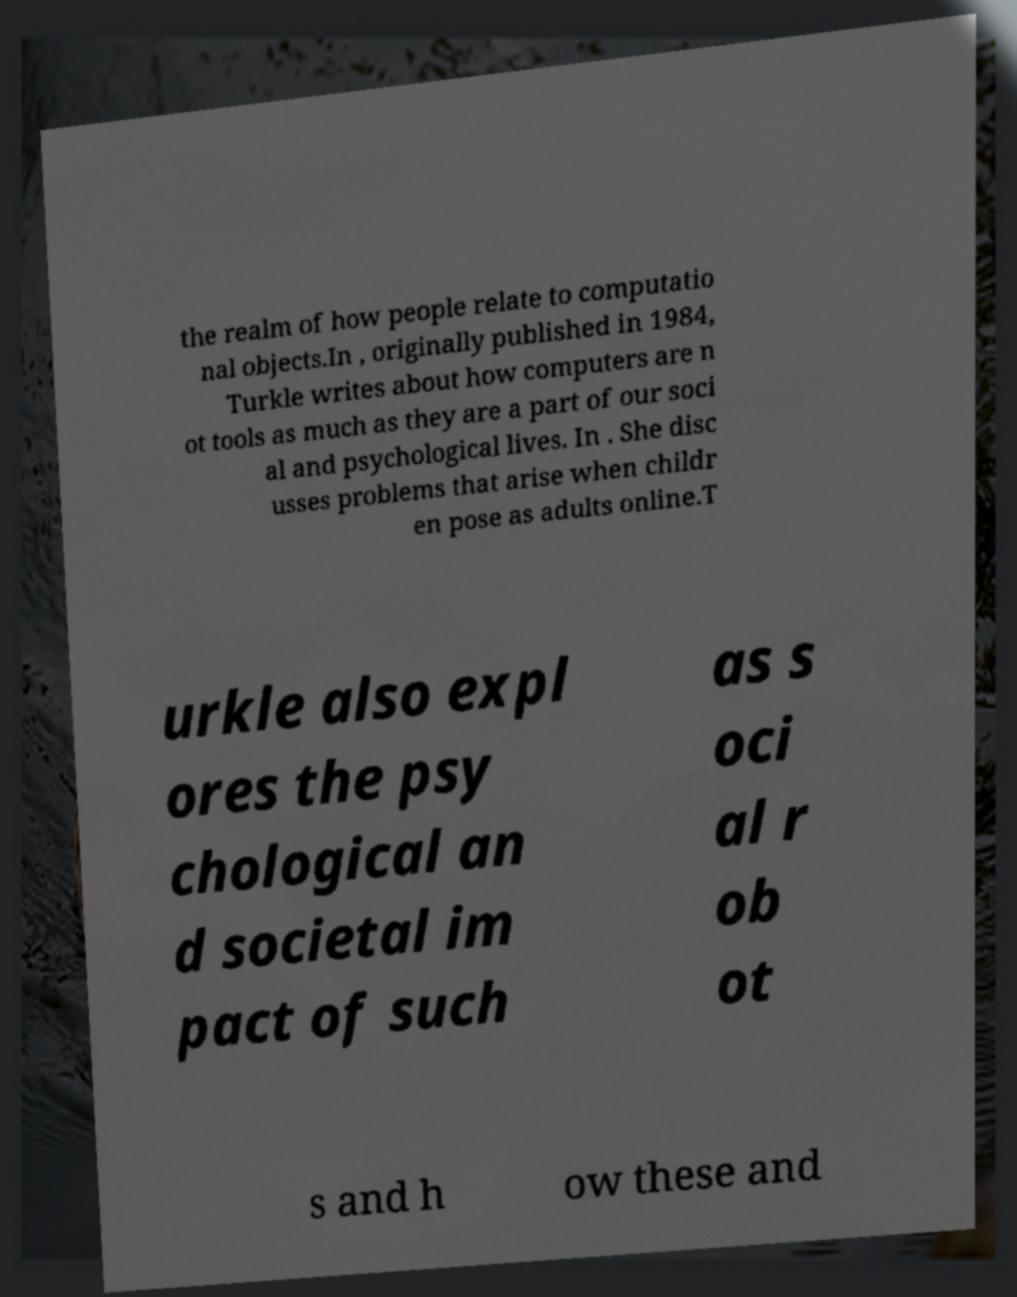Could you extract and type out the text from this image? the realm of how people relate to computatio nal objects.In , originally published in 1984, Turkle writes about how computers are n ot tools as much as they are a part of our soci al and psychological lives. In . She disc usses problems that arise when childr en pose as adults online.T urkle also expl ores the psy chological an d societal im pact of such as s oci al r ob ot s and h ow these and 